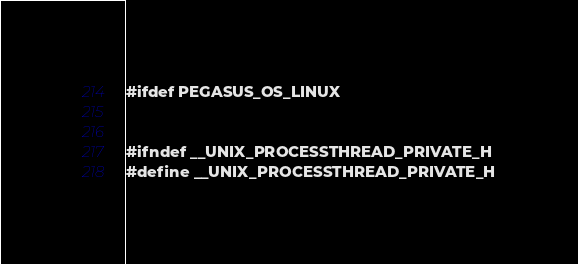<code> <loc_0><loc_0><loc_500><loc_500><_C++_>#ifdef PEGASUS_OS_LINUX


#ifndef __UNIX_PROCESSTHREAD_PRIVATE_H
#define __UNIX_PROCESSTHREAD_PRIVATE_H

</code> 